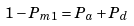<formula> <loc_0><loc_0><loc_500><loc_500>1 - P _ { m 1 } = P _ { a } + P _ { d }</formula> 